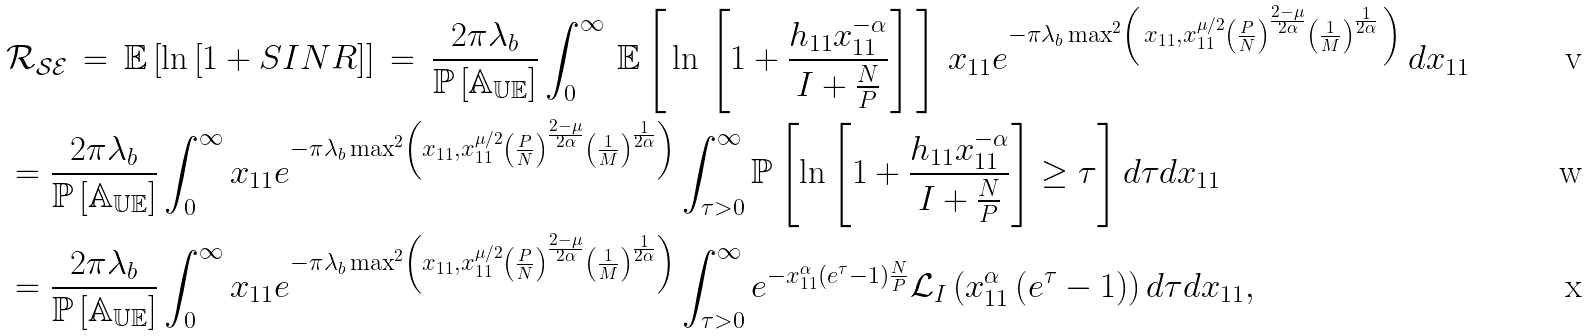Convert formula to latex. <formula><loc_0><loc_0><loc_500><loc_500>& \mathcal { R _ { S E } } \, = \, \mathbb { E } \left [ \ln \left [ 1 + S I N R \right ] \right ] \, = \, \frac { 2 \pi \lambda _ { b } } { \mathbb { P } \left [ \mathbb { A _ { U E } } \right ] } \int _ { 0 } ^ { \infty } \, \mathbb { E } \left [ \, \ln \, \left [ 1 + \frac { h _ { 1 1 } x _ { 1 1 } ^ { - \alpha } } { I + \frac { N } { P } } \right ] \, \right ] \, x _ { 1 1 } e ^ { - \pi \lambda _ { b } \max ^ { 2 } \left ( \, x _ { 1 1 } , x _ { 1 1 } ^ { \mu / 2 } \left ( \frac { P } { N } \right ) ^ { \frac { 2 - \mu } { 2 \alpha } } \left ( \frac { 1 } { M } \right ) ^ { \frac { 1 } { 2 \alpha } } \, \right ) } \, d x _ { 1 1 } \\ & = \frac { 2 \pi \lambda _ { b } } { \mathbb { P } \left [ \mathbb { A _ { U E } } \right ] } \int _ { 0 } ^ { \infty } x _ { 1 1 } e ^ { - \pi \lambda _ { b } \max ^ { 2 } \left ( x _ { 1 1 } , x _ { 1 1 } ^ { \mu / 2 } \left ( \frac { P } { N } \right ) ^ { \frac { 2 - \mu } { 2 \alpha } } \left ( \frac { 1 } { M } \right ) ^ { \frac { 1 } { 2 \alpha } } \right ) } \int _ { \tau > 0 } ^ { \infty } \mathbb { P } \left [ \ln \left [ 1 + \frac { h _ { 1 1 } x _ { 1 1 } ^ { - \alpha } } { I + \frac { N } { P } } \right ] \geq \tau \right ] d \tau d x _ { 1 1 } \\ & = \frac { 2 \pi \lambda _ { b } } { \mathbb { P } \left [ \mathbb { A _ { U E } } \right ] } \int _ { 0 } ^ { \infty } x _ { 1 1 } e ^ { - \pi \lambda _ { b } \max ^ { 2 } \left ( x _ { 1 1 } , x _ { 1 1 } ^ { \mu / 2 } \left ( \frac { P } { N } \right ) ^ { \frac { 2 - \mu } { 2 \alpha } } \left ( \frac { 1 } { M } \right ) ^ { \frac { 1 } { 2 \alpha } } \right ) } \int _ { \tau > 0 } ^ { \infty } e ^ { - x _ { 1 1 } ^ { \alpha } \left ( e ^ { \tau } - 1 \right ) \frac { N } { P } } \mathcal { L } _ { I } \left ( x _ { 1 1 } ^ { \alpha } \left ( e ^ { \tau } - 1 \right ) \right ) d \tau d x _ { 1 1 } ,</formula> 